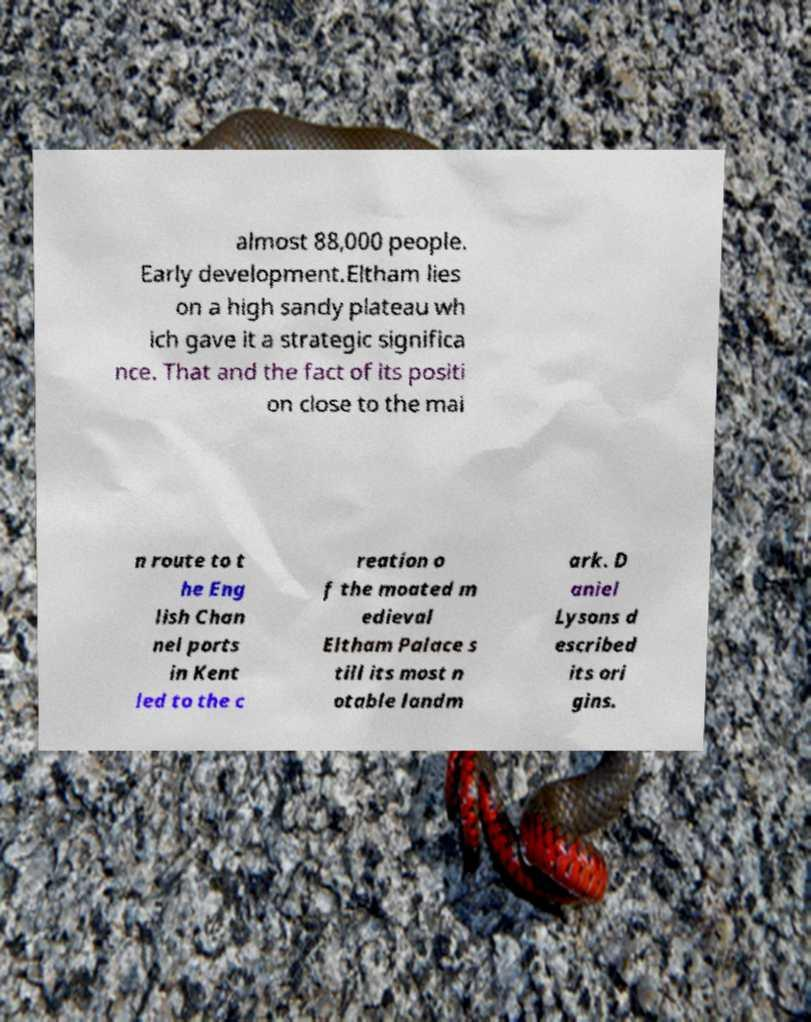What messages or text are displayed in this image? I need them in a readable, typed format. almost 88,000 people. Early development.Eltham lies on a high sandy plateau wh ich gave it a strategic significa nce. That and the fact of its positi on close to the mai n route to t he Eng lish Chan nel ports in Kent led to the c reation o f the moated m edieval Eltham Palace s till its most n otable landm ark. D aniel Lysons d escribed its ori gins. 